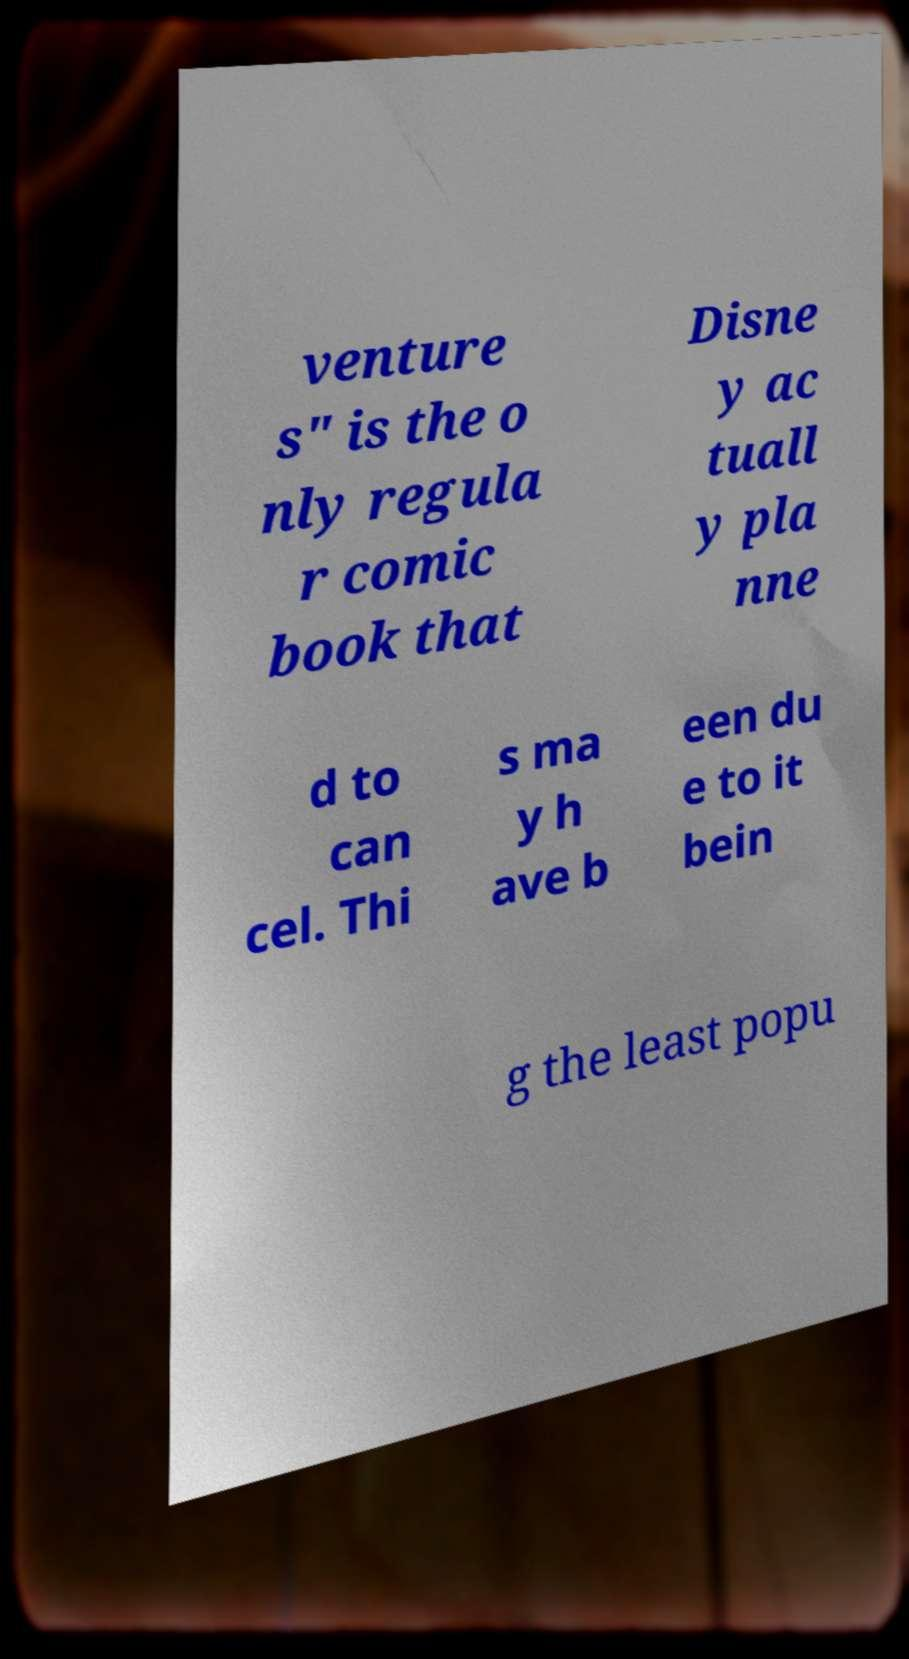There's text embedded in this image that I need extracted. Can you transcribe it verbatim? venture s" is the o nly regula r comic book that Disne y ac tuall y pla nne d to can cel. Thi s ma y h ave b een du e to it bein g the least popu 